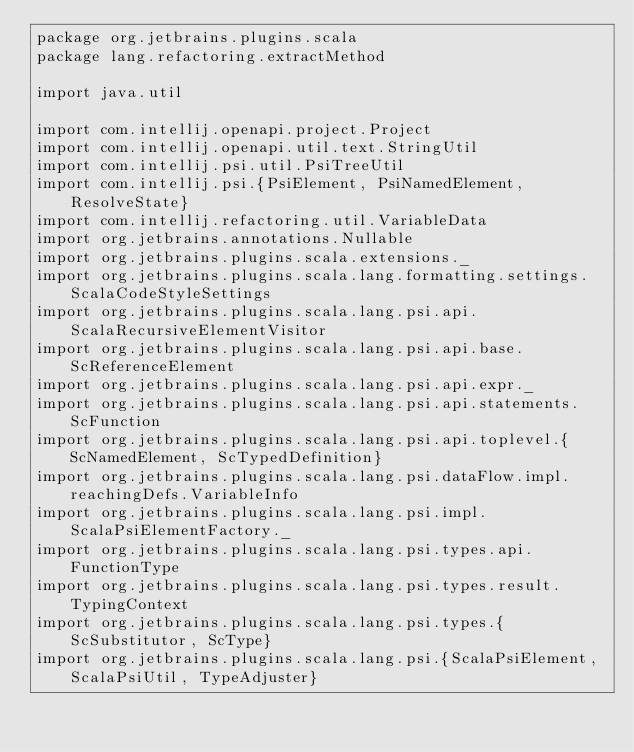<code> <loc_0><loc_0><loc_500><loc_500><_Scala_>package org.jetbrains.plugins.scala
package lang.refactoring.extractMethod

import java.util

import com.intellij.openapi.project.Project
import com.intellij.openapi.util.text.StringUtil
import com.intellij.psi.util.PsiTreeUtil
import com.intellij.psi.{PsiElement, PsiNamedElement, ResolveState}
import com.intellij.refactoring.util.VariableData
import org.jetbrains.annotations.Nullable
import org.jetbrains.plugins.scala.extensions._
import org.jetbrains.plugins.scala.lang.formatting.settings.ScalaCodeStyleSettings
import org.jetbrains.plugins.scala.lang.psi.api.ScalaRecursiveElementVisitor
import org.jetbrains.plugins.scala.lang.psi.api.base.ScReferenceElement
import org.jetbrains.plugins.scala.lang.psi.api.expr._
import org.jetbrains.plugins.scala.lang.psi.api.statements.ScFunction
import org.jetbrains.plugins.scala.lang.psi.api.toplevel.{ScNamedElement, ScTypedDefinition}
import org.jetbrains.plugins.scala.lang.psi.dataFlow.impl.reachingDefs.VariableInfo
import org.jetbrains.plugins.scala.lang.psi.impl.ScalaPsiElementFactory._
import org.jetbrains.plugins.scala.lang.psi.types.api.FunctionType
import org.jetbrains.plugins.scala.lang.psi.types.result.TypingContext
import org.jetbrains.plugins.scala.lang.psi.types.{ScSubstitutor, ScType}
import org.jetbrains.plugins.scala.lang.psi.{ScalaPsiElement, ScalaPsiUtil, TypeAdjuster}</code> 